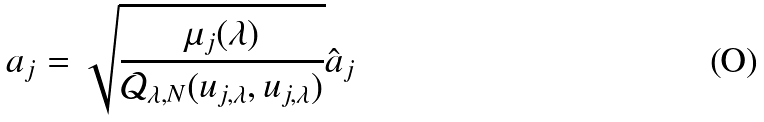<formula> <loc_0><loc_0><loc_500><loc_500>a _ { j } = \sqrt { \frac { \mu _ { j } ( \lambda ) } { \mathcal { Q } _ { \lambda , N } ( u _ { j , \lambda } , u _ { j , \lambda } ) } } \hat { a } _ { j }</formula> 